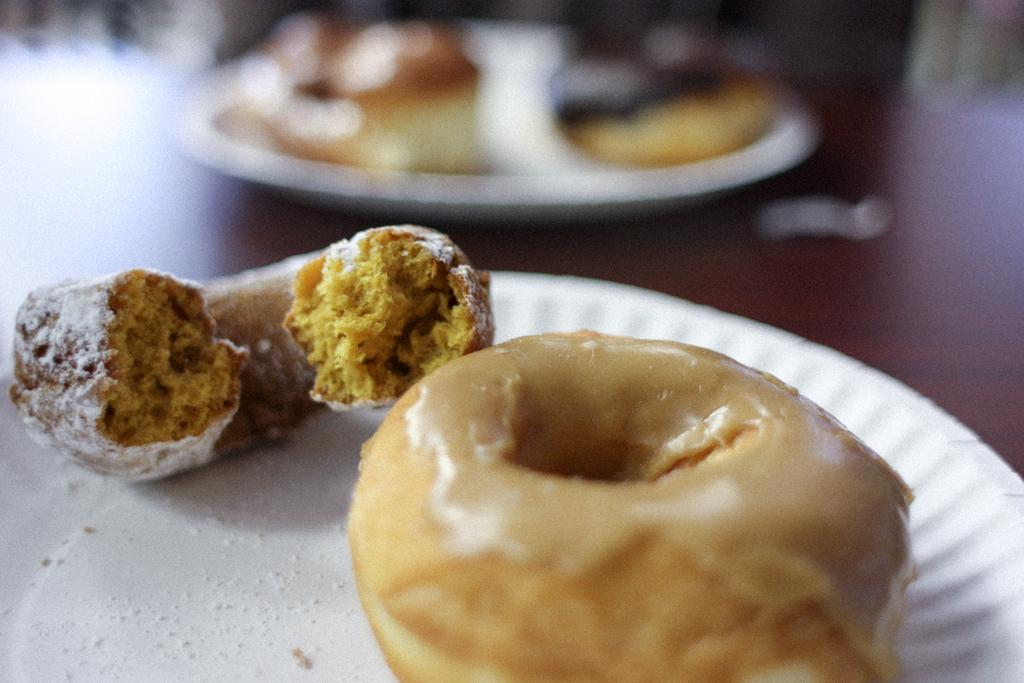How many plates can be seen in the image? There are two plates in the image. Where are the plates located? The plates are on a surface. What is on the plates? There are doughnuts on the plates. Can you describe the background of the image? The background of the image is blurry. What type of waste is visible in the image? There is no waste visible in the image; it features two plates with doughnuts on them. What kind of bait is used to attract the creatures in the image? There are no creatures or bait present in the image. 